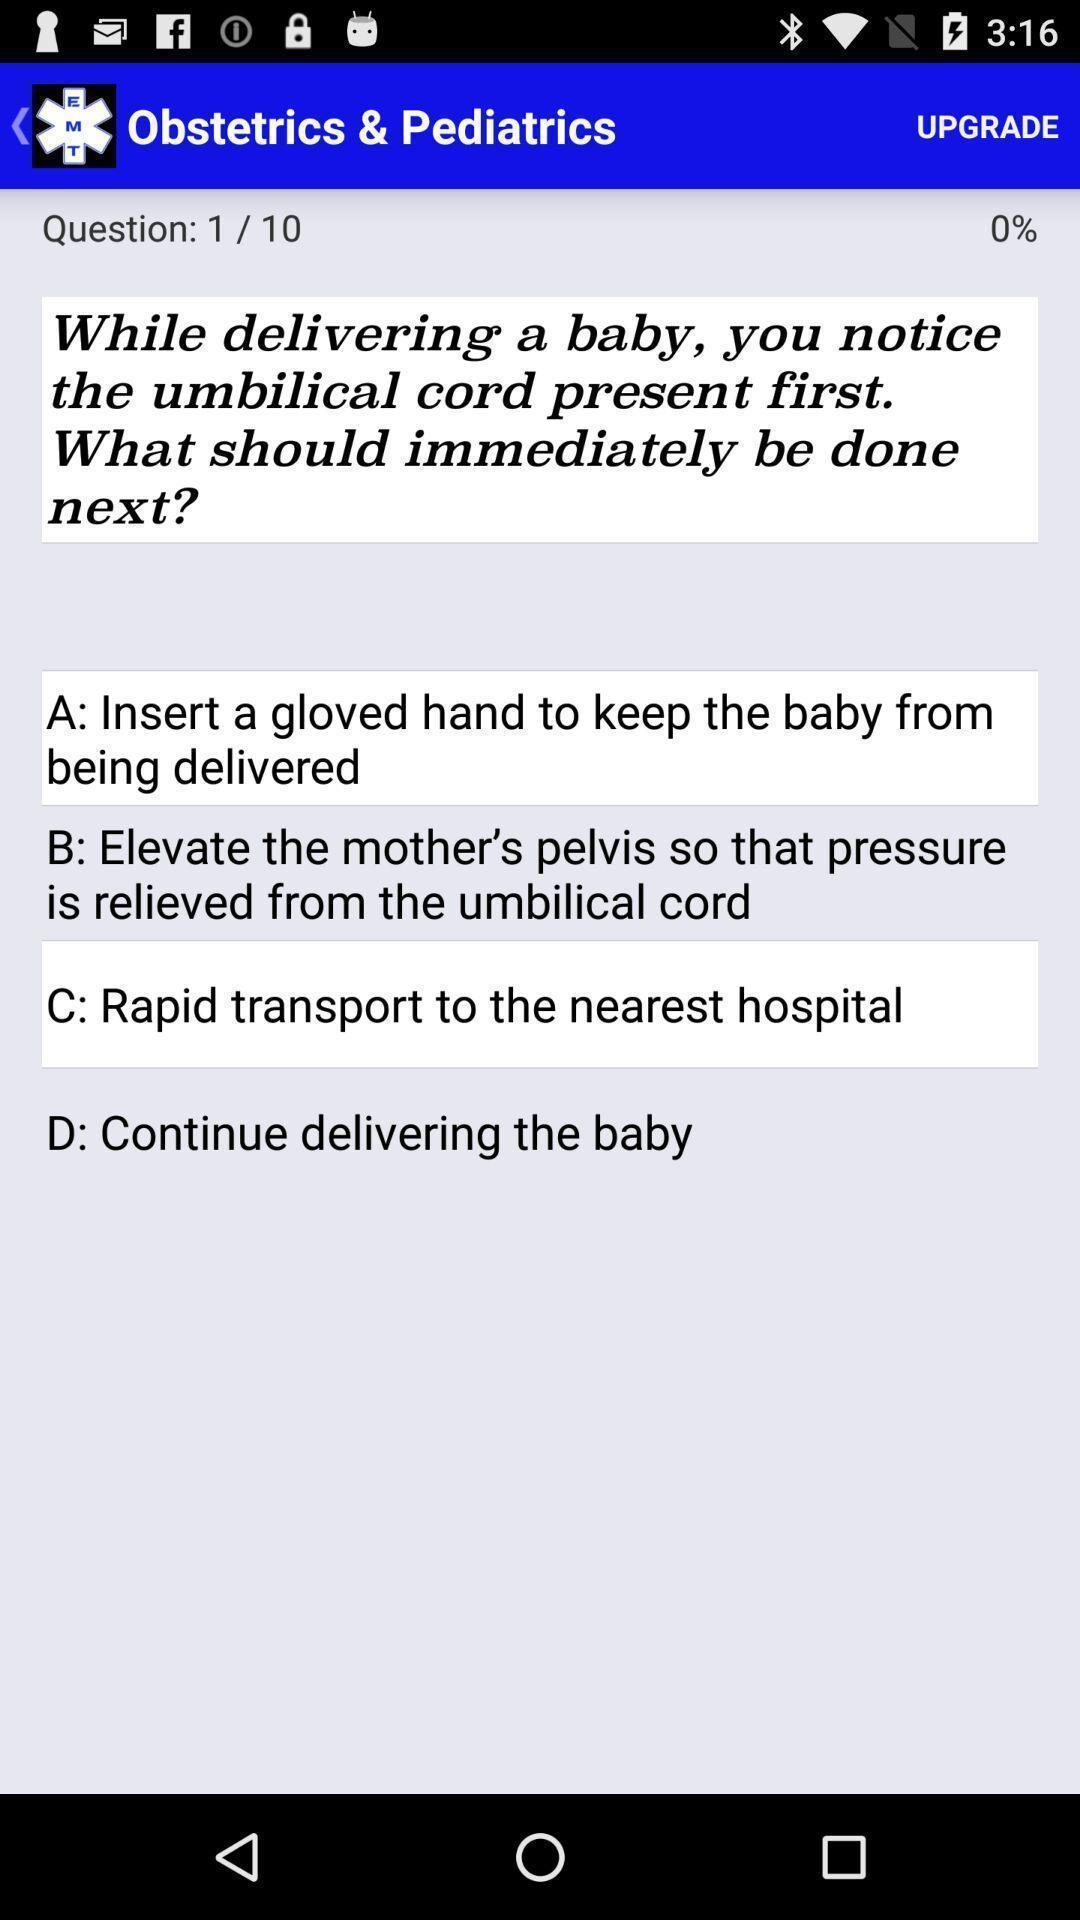What can you discern from this picture? Screen shows a question in a health app. 